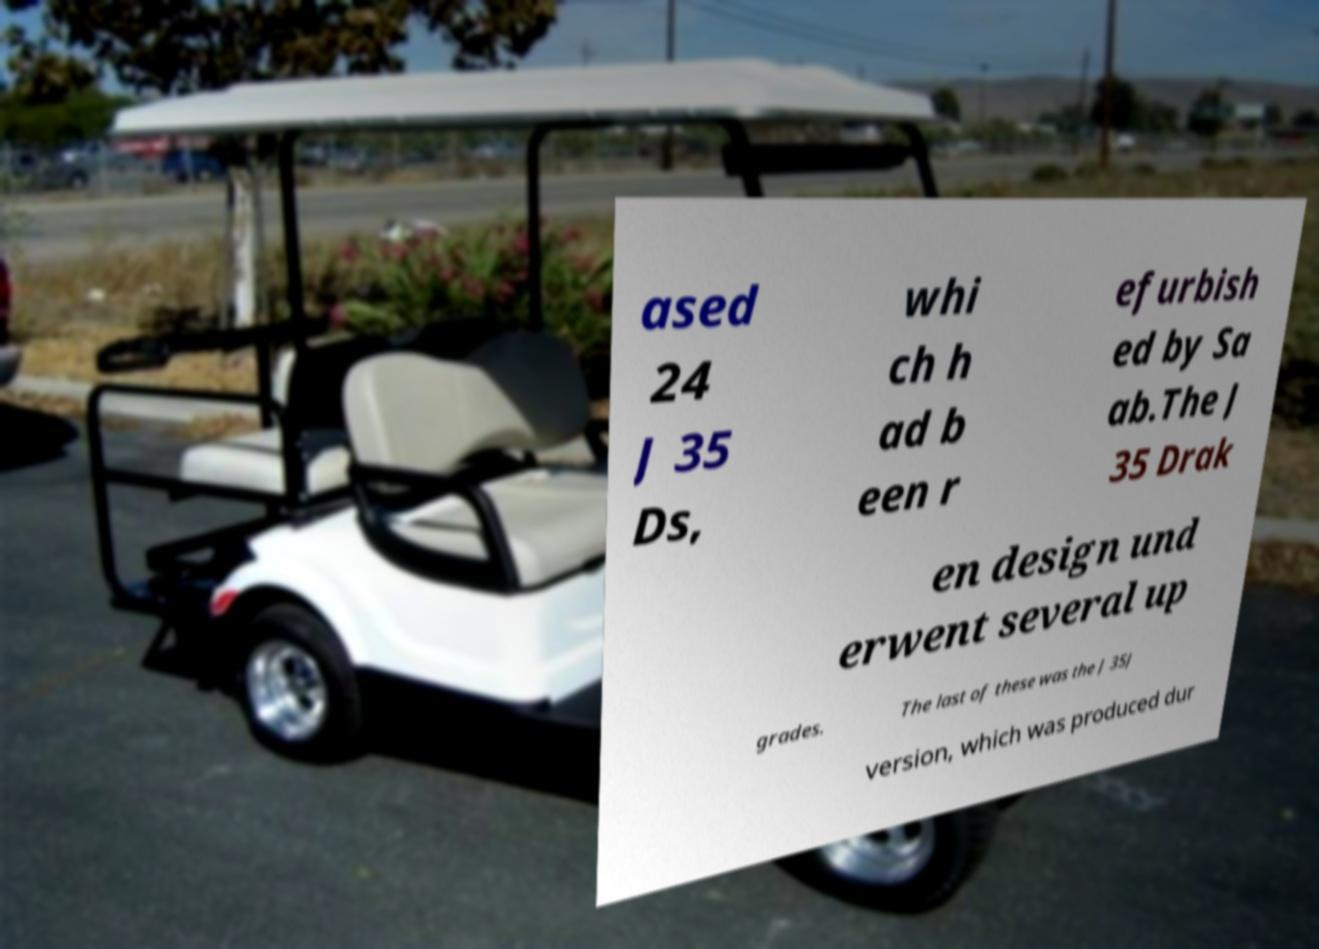Could you assist in decoding the text presented in this image and type it out clearly? ased 24 J 35 Ds, whi ch h ad b een r efurbish ed by Sa ab.The J 35 Drak en design und erwent several up grades. The last of these was the J 35J version, which was produced dur 